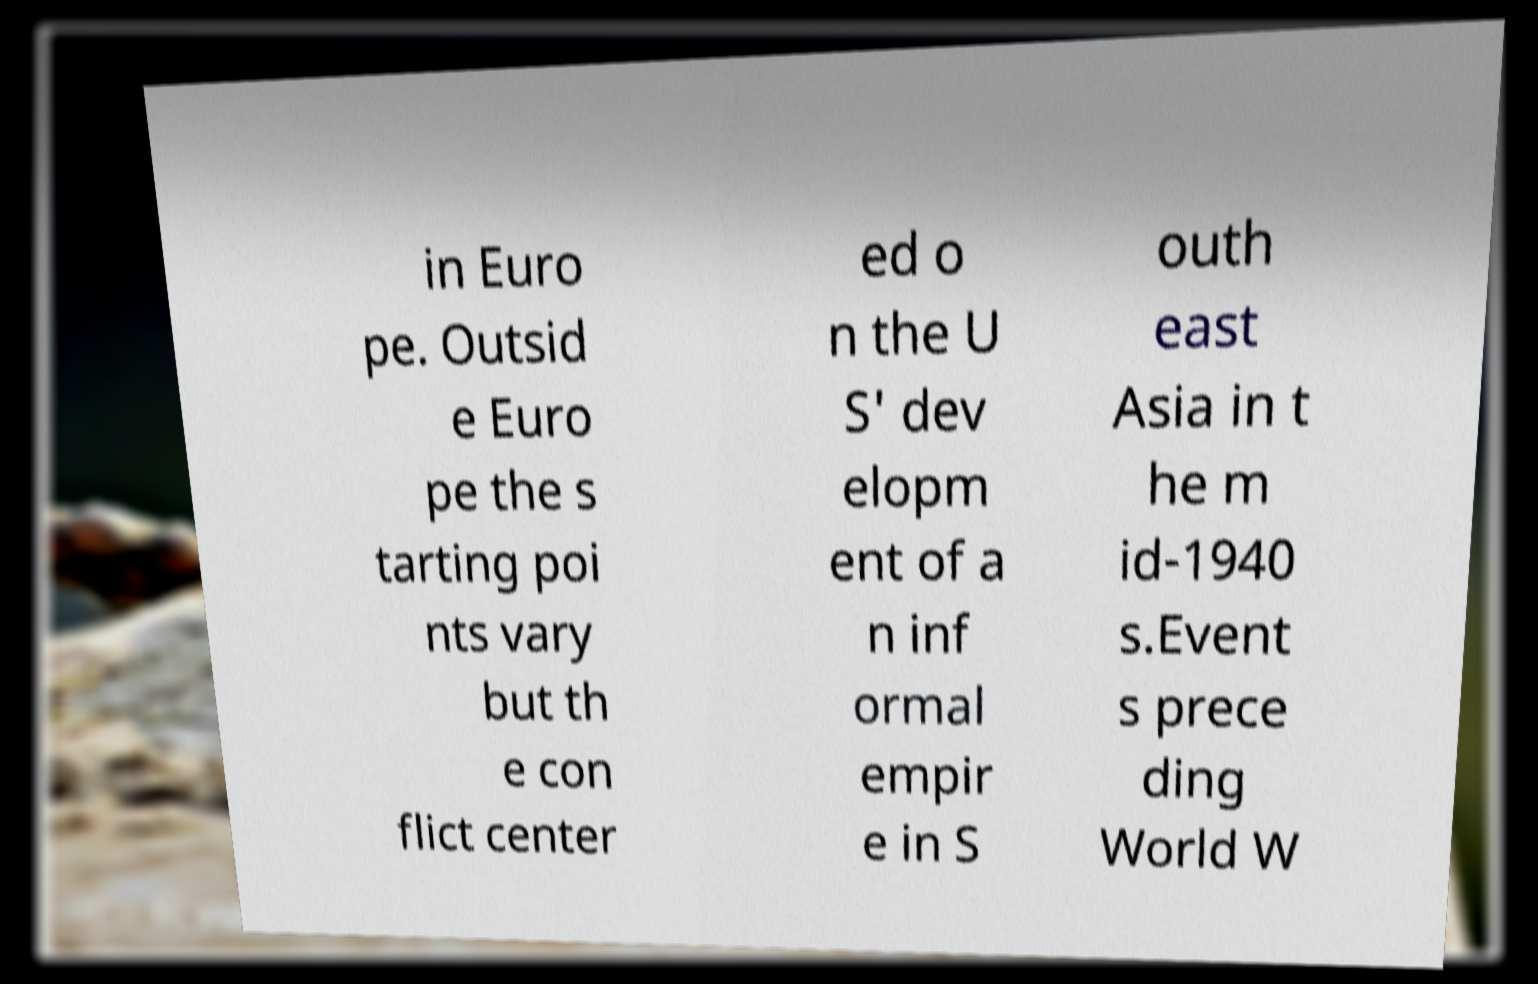Could you extract and type out the text from this image? in Euro pe. Outsid e Euro pe the s tarting poi nts vary but th e con flict center ed o n the U S' dev elopm ent of a n inf ormal empir e in S outh east Asia in t he m id-1940 s.Event s prece ding World W 